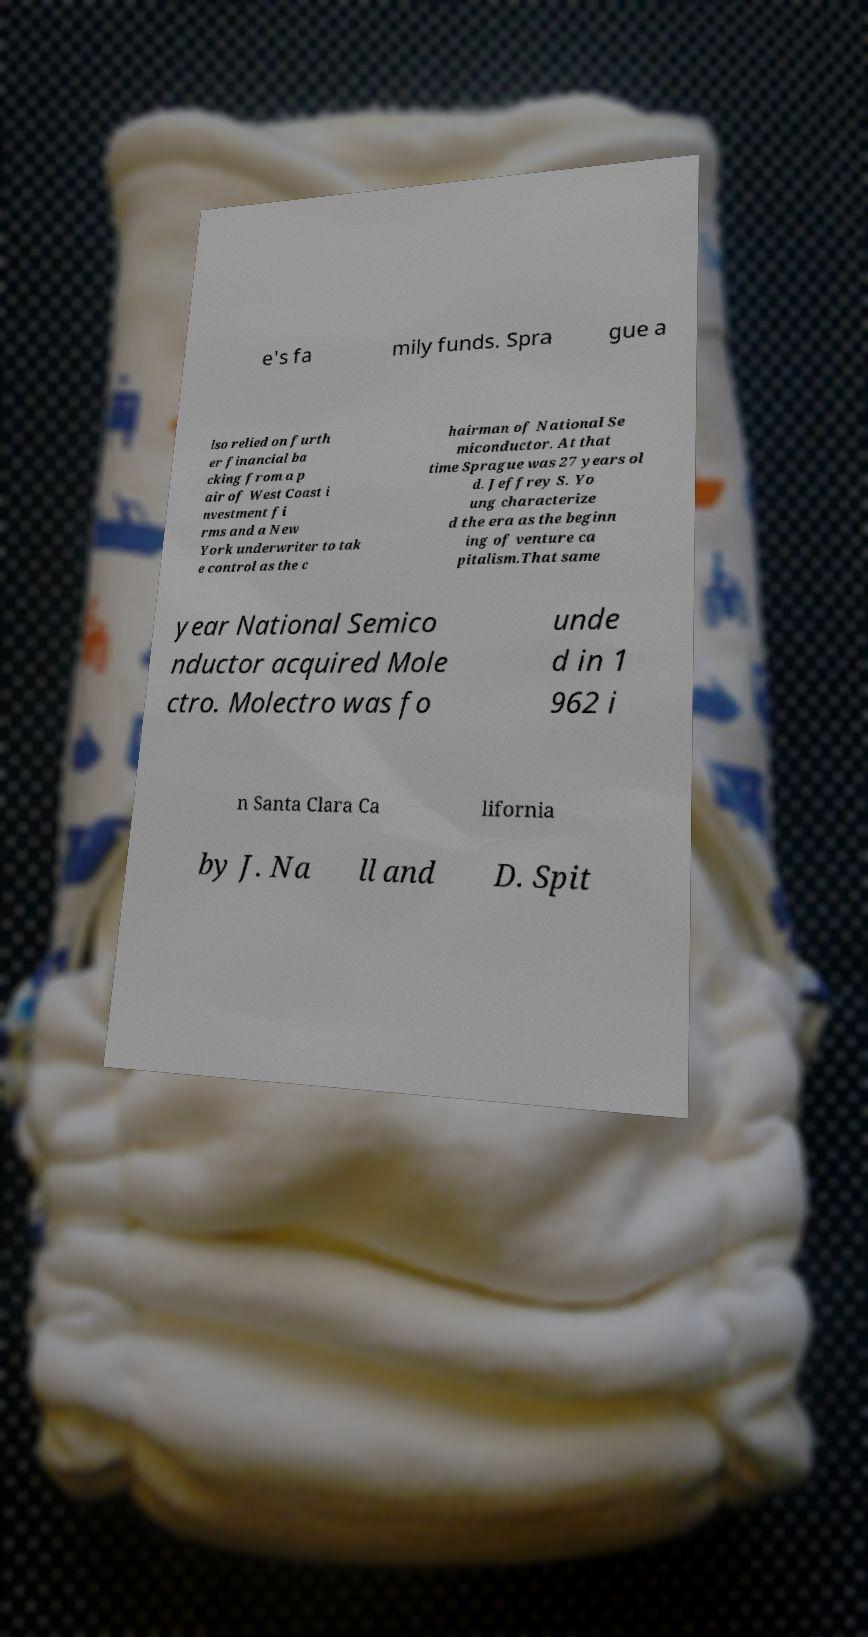What messages or text are displayed in this image? I need them in a readable, typed format. e's fa mily funds. Spra gue a lso relied on furth er financial ba cking from a p air of West Coast i nvestment fi rms and a New York underwriter to tak e control as the c hairman of National Se miconductor. At that time Sprague was 27 years ol d. Jeffrey S. Yo ung characterize d the era as the beginn ing of venture ca pitalism.That same year National Semico nductor acquired Mole ctro. Molectro was fo unde d in 1 962 i n Santa Clara Ca lifornia by J. Na ll and D. Spit 